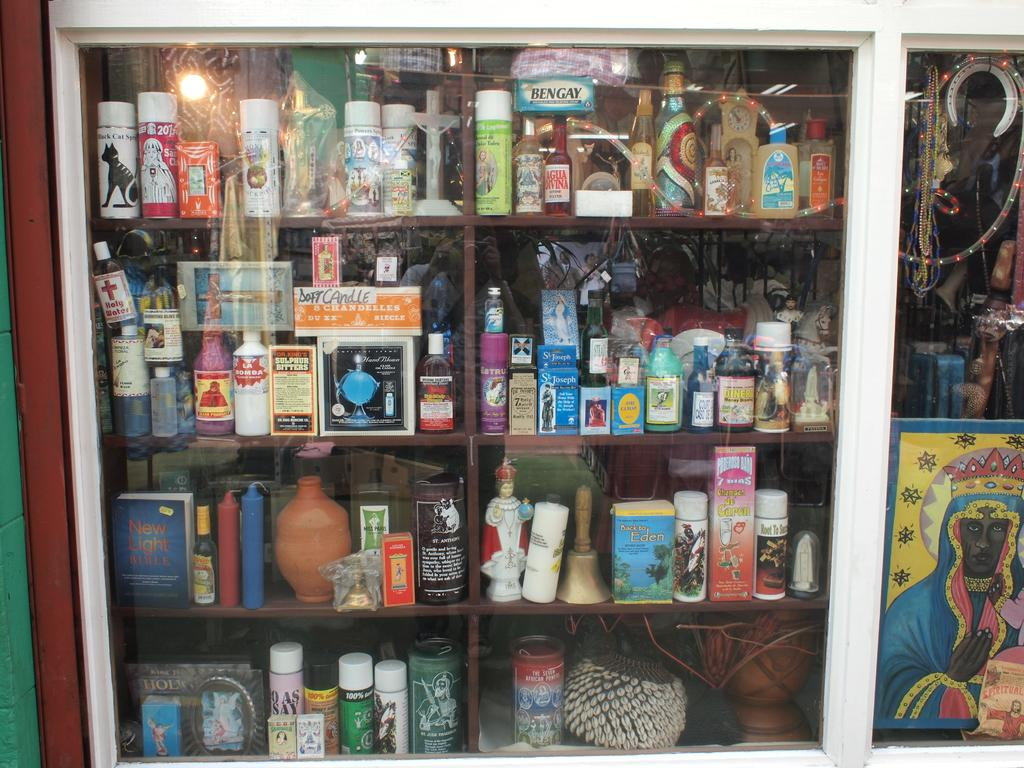<image>
Summarize the visual content of the image. shelves behind a glass with an item labeled 'la bomba' 